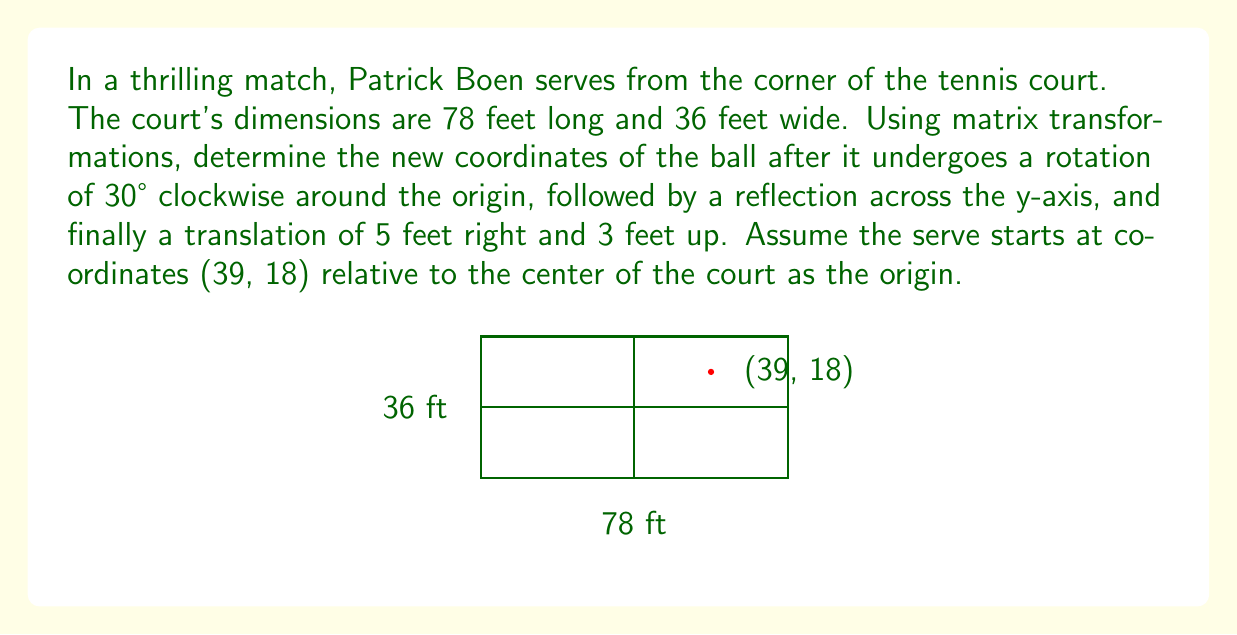Help me with this question. Let's approach this step-by-step:

1) First, we need to create the rotation matrix for 30° clockwise:
   $$R = \begin{pmatrix} \cos(-30°) & -\sin(-30°) \\ \sin(-30°) & \cos(-30°) \end{pmatrix} = \begin{pmatrix} \frac{\sqrt{3}}{2} & \frac{1}{2} \\ -\frac{1}{2} & \frac{\sqrt{3}}{2} \end{pmatrix}$$

2) Apply the rotation to the initial coordinates:
   $$\begin{pmatrix} \frac{\sqrt{3}}{2} & \frac{1}{2} \\ -\frac{1}{2} & \frac{\sqrt{3}}{2} \end{pmatrix} \begin{pmatrix} 39 \\ 18 \end{pmatrix} = \begin{pmatrix} 39\frac{\sqrt{3}}{2} + 9 \\ -19.5 + 18\frac{\sqrt{3}}{2} \end{pmatrix} \approx \begin{pmatrix} 42.81 \\ 11.83 \end{pmatrix}$$

3) Next, we apply the reflection across the y-axis. This is done by multiplying the x-coordinate by -1:
   $$\begin{pmatrix} -42.81 \\ 11.83 \end{pmatrix}$$

4) Finally, we apply the translation of 5 feet right and 3 feet up:
   $$\begin{pmatrix} -42.81 + 5 \\ 11.83 + 3 \end{pmatrix} = \begin{pmatrix} -37.81 \\ 14.83 \end{pmatrix}$$

Therefore, the final coordinates of the ball after all transformations are approximately (-37.81, 14.83).
Answer: $(-37.81, 14.83)$ 